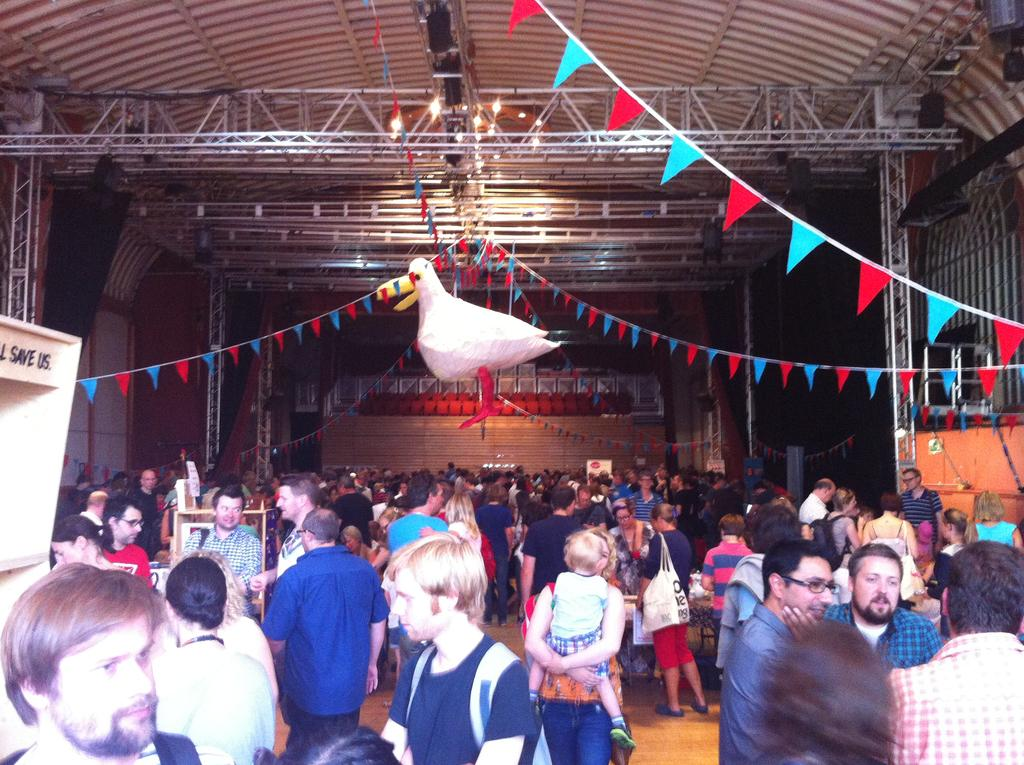How many people are in the image? There is a group of people in the image, but the exact number is not specified. What is the position of the people in the image? The people are standing on the floor in the image. What items can be seen in the image besides the people? There are bags, a stand, a bird toy, decorative flags, posters, lights, and some unspecified objects in the image. What type of songs can be heard coming from the net in the image? There is no net present in the image, and therefore no songs can be heard coming from it. 